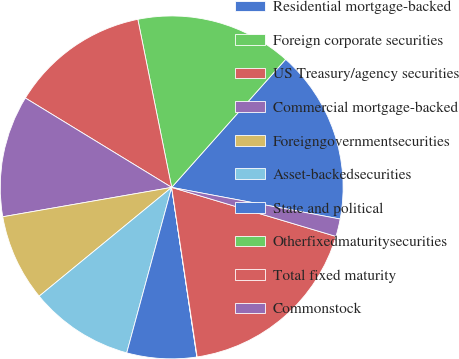Convert chart to OTSL. <chart><loc_0><loc_0><loc_500><loc_500><pie_chart><fcel>Residential mortgage-backed<fcel>Foreign corporate securities<fcel>US Treasury/agency securities<fcel>Commercial mortgage-backed<fcel>Foreigngovernmentsecurities<fcel>Asset-backedsecurities<fcel>State and political<fcel>Otherfixedmaturitysecurities<fcel>Total fixed maturity<fcel>Commonstock<nl><fcel>16.38%<fcel>14.74%<fcel>13.11%<fcel>11.47%<fcel>8.2%<fcel>9.84%<fcel>6.57%<fcel>0.03%<fcel>18.01%<fcel>1.66%<nl></chart> 